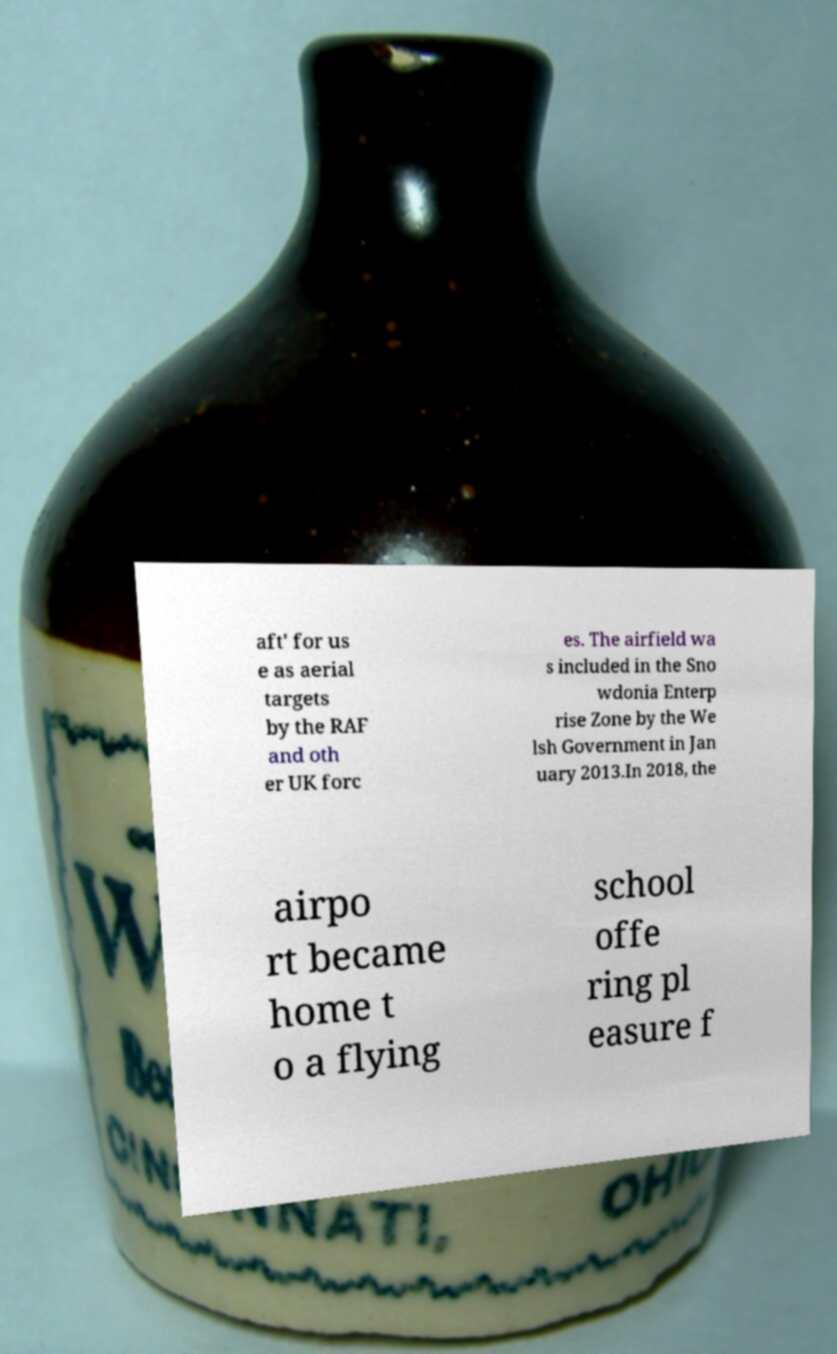Please identify and transcribe the text found in this image. aft' for us e as aerial targets by the RAF and oth er UK forc es. The airfield wa s included in the Sno wdonia Enterp rise Zone by the We lsh Government in Jan uary 2013.In 2018, the airpo rt became home t o a flying school offe ring pl easure f 